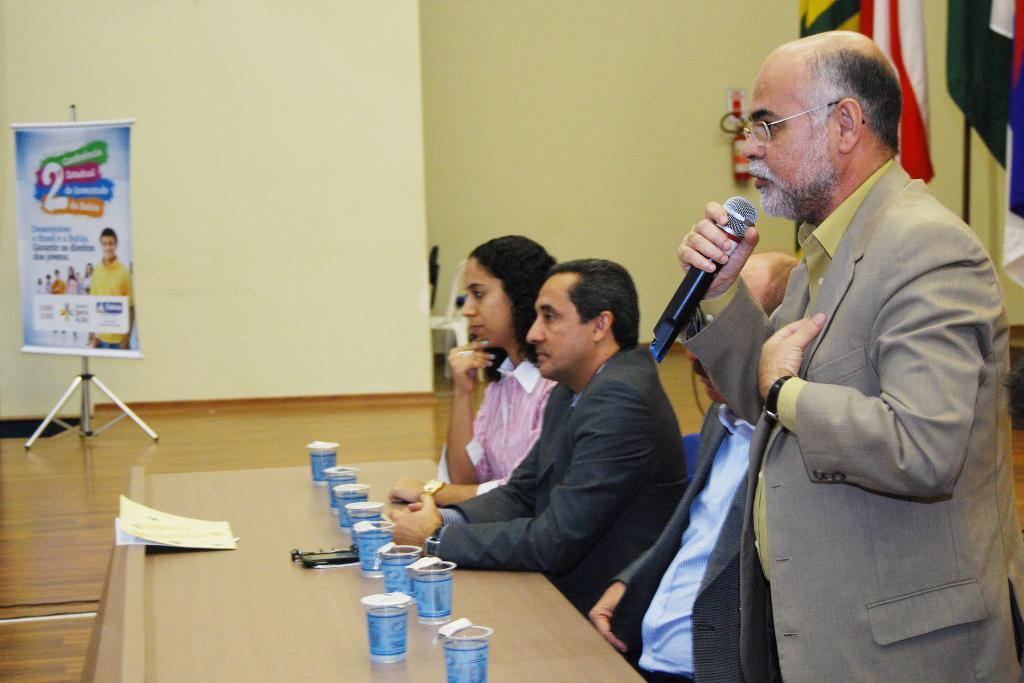In one or two sentences, can you explain what this image depicts? In this image there are group of persons sitting and at the right side of the image there is a person wearing suit standing and holding microphone in his hand and at the front there are glasses. 